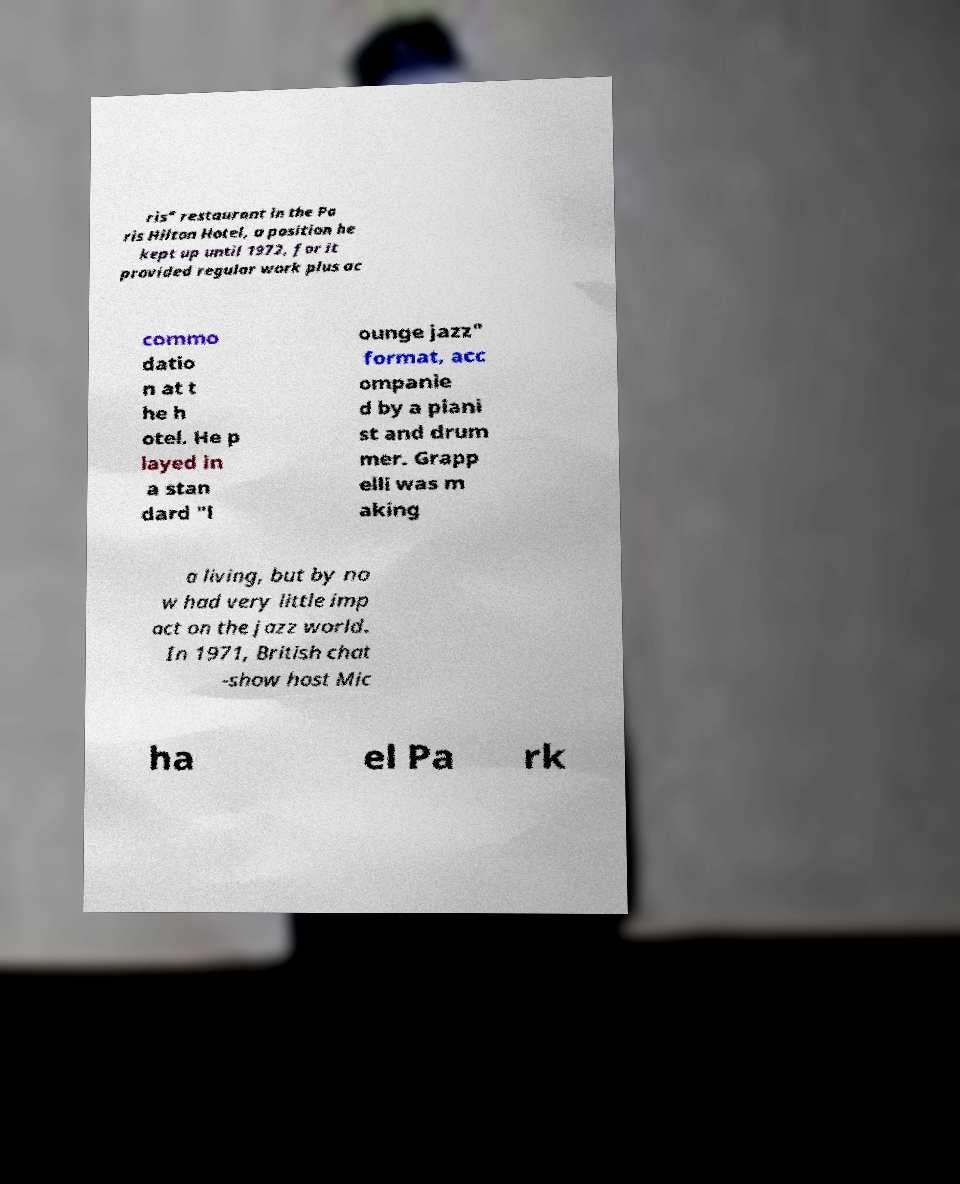There's text embedded in this image that I need extracted. Can you transcribe it verbatim? ris" restaurant in the Pa ris Hilton Hotel, a position he kept up until 1972, for it provided regular work plus ac commo datio n at t he h otel. He p layed in a stan dard "l ounge jazz" format, acc ompanie d by a piani st and drum mer. Grapp elli was m aking a living, but by no w had very little imp act on the jazz world. In 1971, British chat -show host Mic ha el Pa rk 